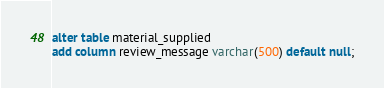Convert code to text. <code><loc_0><loc_0><loc_500><loc_500><_SQL_>
alter table material_supplied
add column review_message varchar(500) default null;</code> 